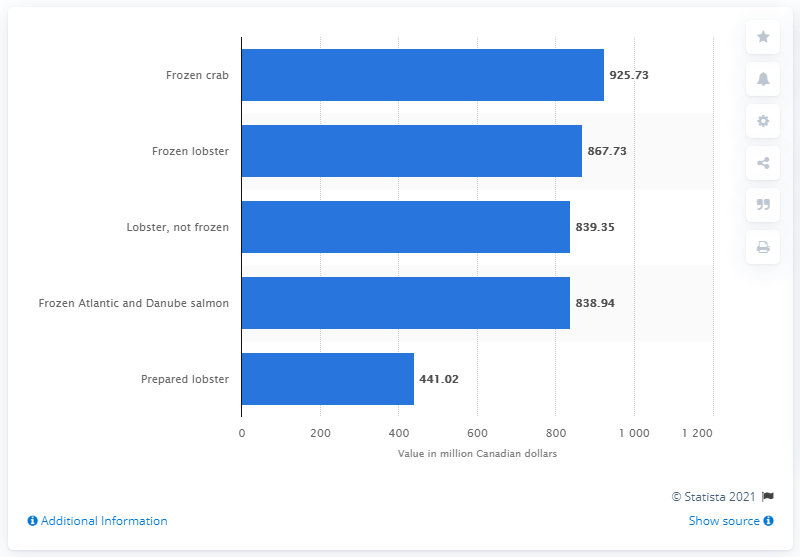Draw attention to some important aspects in this diagram. In 2016, the value of frozen lobster exported from Canada was 867.73 Canadian dollars. 